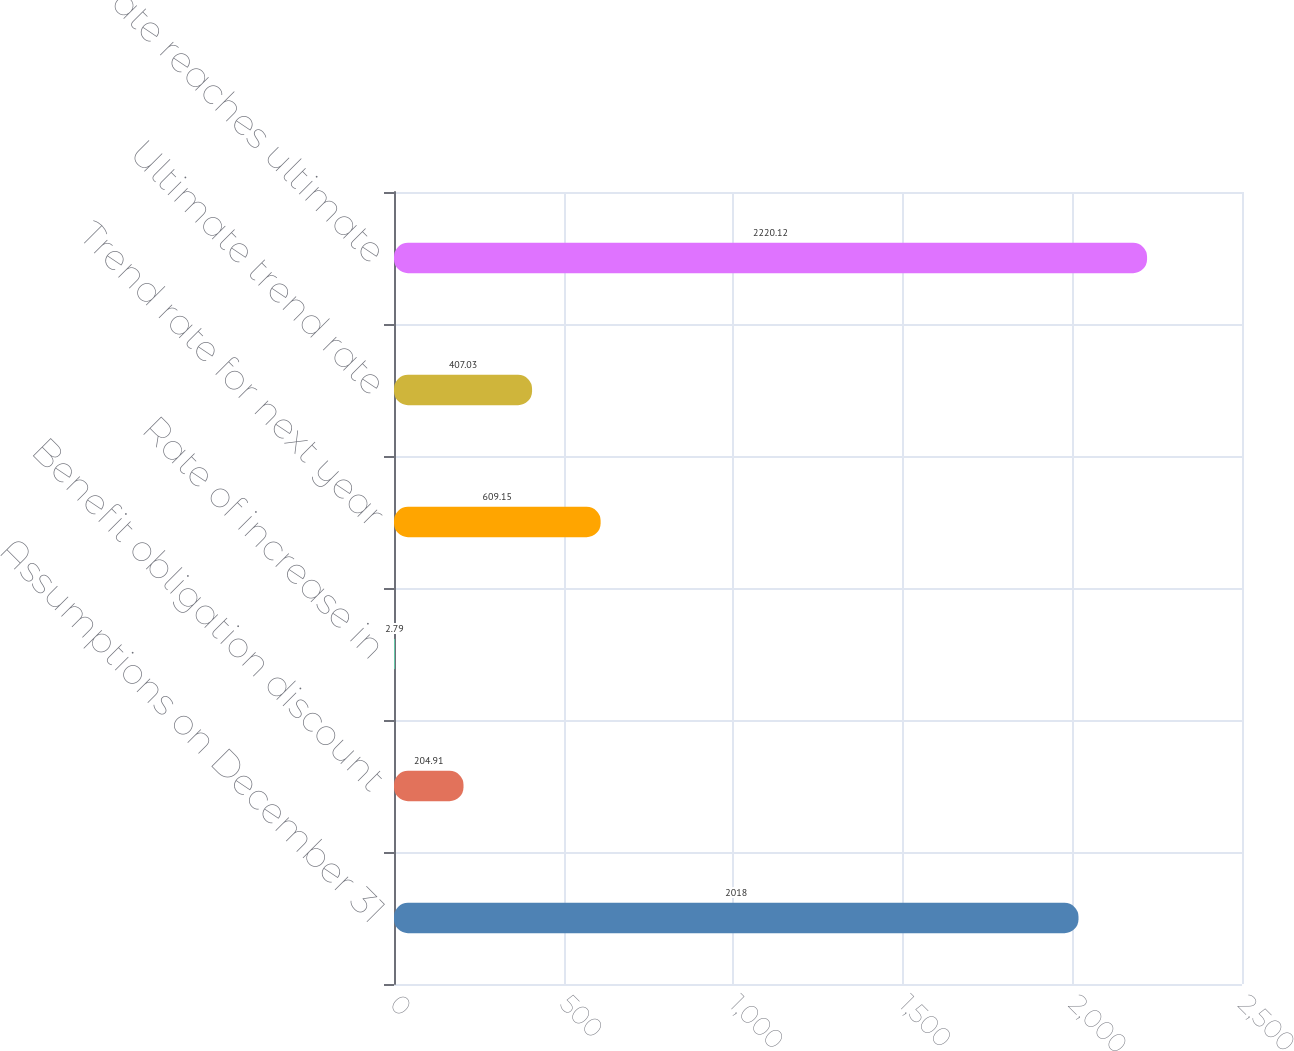<chart> <loc_0><loc_0><loc_500><loc_500><bar_chart><fcel>Assumptions on December 31<fcel>Benefit obligation discount<fcel>Rate of increase in<fcel>Trend rate for next year<fcel>Ultimate trend rate<fcel>Year rate reaches ultimate<nl><fcel>2018<fcel>204.91<fcel>2.79<fcel>609.15<fcel>407.03<fcel>2220.12<nl></chart> 